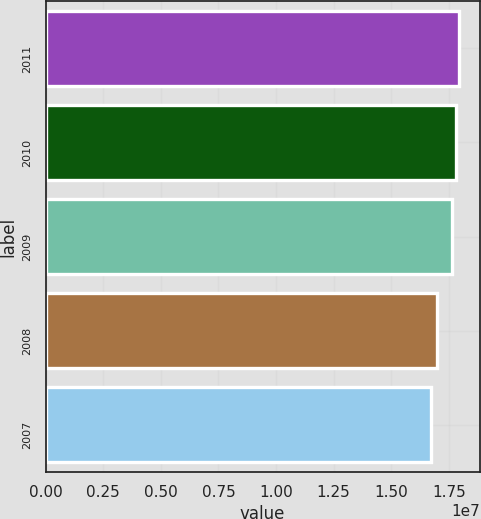<chart> <loc_0><loc_0><loc_500><loc_500><bar_chart><fcel>2011<fcel>2010<fcel>2009<fcel>2008<fcel>2007<nl><fcel>1.7944e+07<fcel>1.7823e+07<fcel>1.7646e+07<fcel>1.6981e+07<fcel>1.6715e+07<nl></chart> 